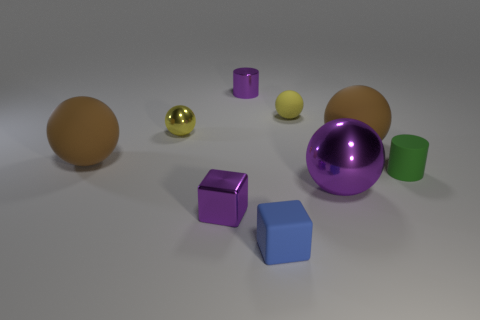There is a brown thing behind the large object that is to the left of the yellow metallic thing; what size is it?
Offer a terse response. Large. What is the color of the ball that is both in front of the yellow shiny ball and left of the tiny metal block?
Make the answer very short. Brown. How many other objects are the same size as the purple cylinder?
Your response must be concise. 5. Do the yellow rubber ball and the shiny cylinder right of the purple cube have the same size?
Provide a succinct answer. Yes. What color is the matte cube that is the same size as the green matte cylinder?
Your answer should be compact. Blue. What is the size of the green cylinder?
Give a very brief answer. Small. Is the material of the tiny purple thing that is behind the green matte object the same as the purple sphere?
Ensure brevity in your answer.  Yes. Is the shape of the large shiny thing the same as the green thing?
Your answer should be compact. No. What is the shape of the tiny metallic object in front of the tiny ball on the left side of the tiny cylinder that is behind the green cylinder?
Provide a short and direct response. Cube. There is a tiny purple object behind the shiny cube; is its shape the same as the green object that is behind the tiny blue matte block?
Your answer should be compact. Yes. 